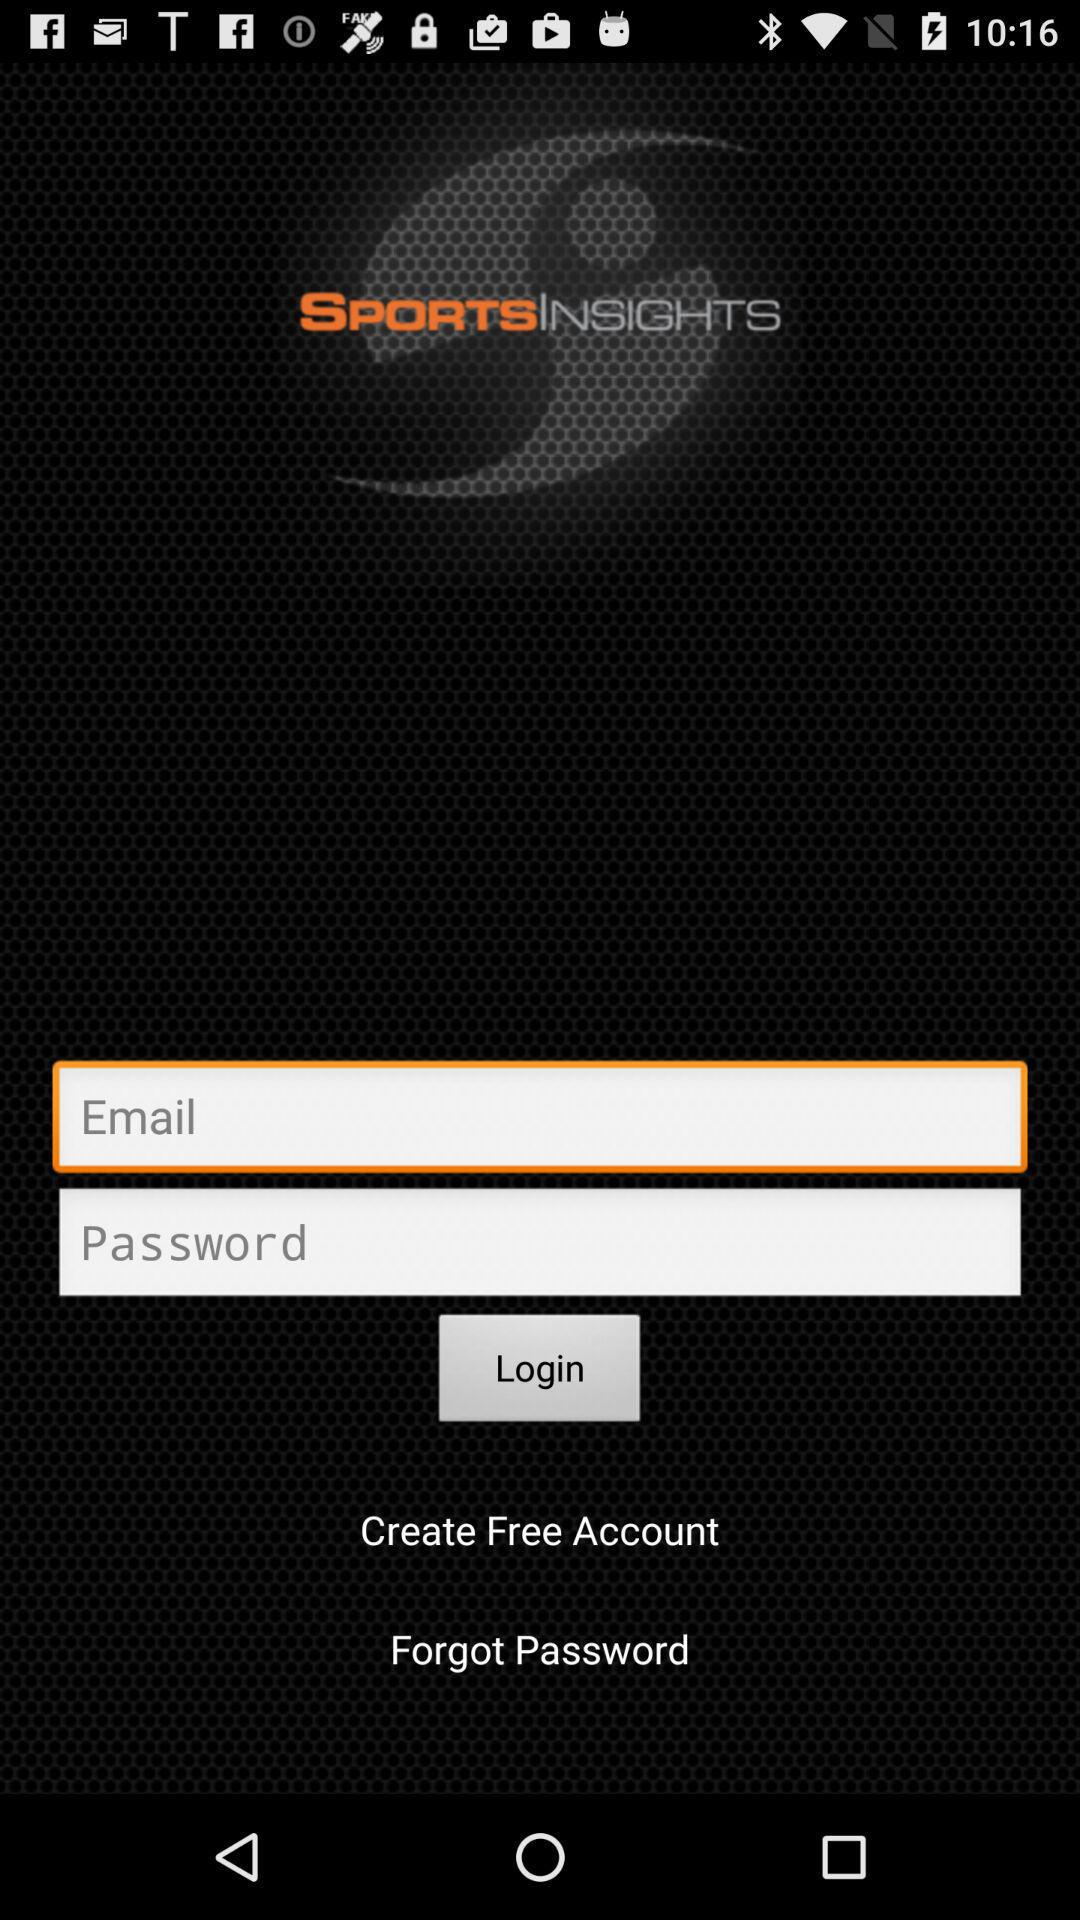What is the name of the application? The name of the application is "SportsInsights". 